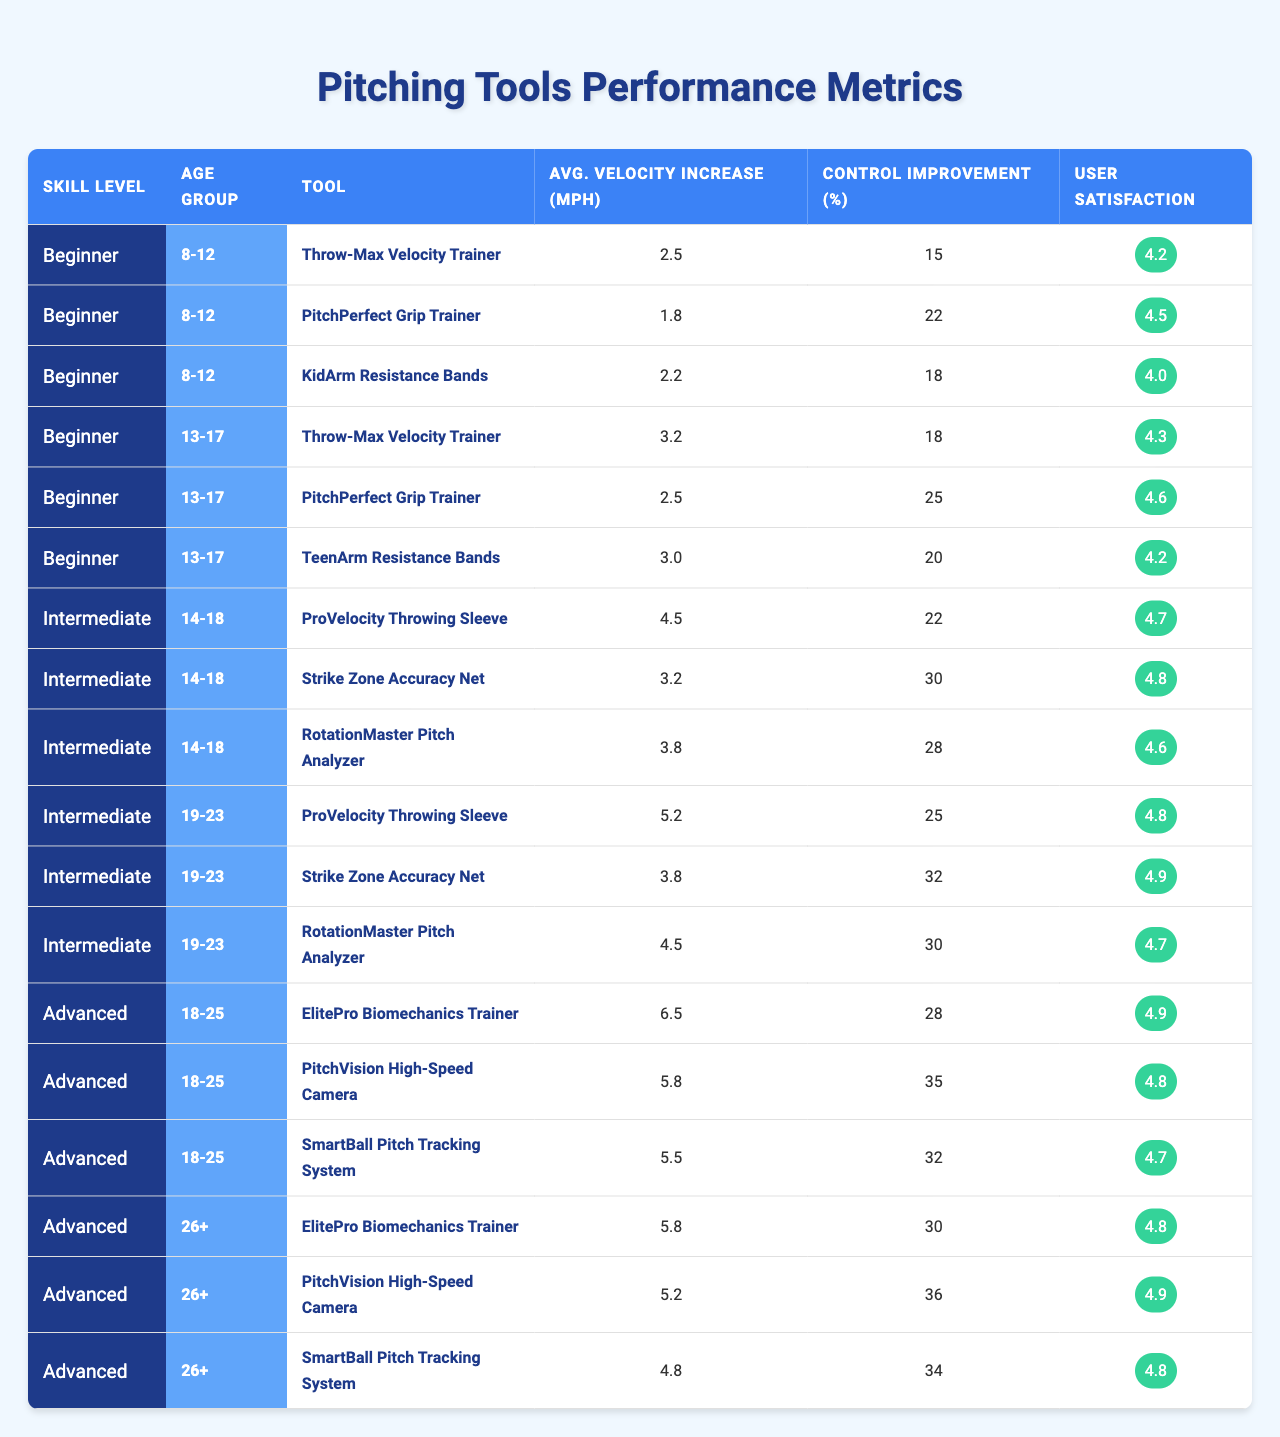What is the highest average velocity increase for tools aimed at the 8-12 age group? For the 8-12 age group, the tools are Throw-Max Velocity Trainer (2.5 mph), PitchPerfect Grip Trainer (1.8 mph), and KidArm Resistance Bands (2.2 mph). The highest average velocity increase is from the Throw-Max Velocity Trainer at 2.5 mph.
Answer: 2.5 mph Which tool has the highest user satisfaction among all age groups? Looking at all the tools across all age groups, the highest user satisfaction is 4.9, which belongs to both the Strike Zone Accuracy Net for the 19-23 age group and the PitchVision High-Speed Camera for the 18-25 age group.
Answer: 4.9 What is the control improvement percentage of the PitchPerfect Grip Trainer for the 13-17 age group? For the 13-17 age group, the PitchPerfect Grip Trainer has a control improvement percentage of 25%.
Answer: 25% Which age group shows the greatest average velocity increase for the Advanced skill level? The Advanced skill level includes the 18-25 and 26+ age groups. The 18-25 age group has an ElitePro Biomechanics Trainer at 6.5 mph, while the 26+ group has it at 5.8 mph. Thus, the greatest average velocity increase is 6.5 mph for the 18-25 age group.
Answer: 18-25 age group Does the ProVelocity Throwing Sleeve provide a higher average velocity increase for the Intermediate skill level than for the Beginner skill level? For the Intermediate skill level, the ProVelocity Throwing Sleeve has an average velocity increase of 4.5 mph (14-18 age group) and 5.2 mph (19-23 age group). For Beginners, it shows 3.2 mph for the 13-17 age group. 4.5 mph and 5.2 mph > 3.2 mph, therefore it is true that it provides a higher increase.
Answer: Yes What is the average user satisfaction for tools used in the Intermediate skill level across both age groups? The user satisfaction scores for the tools in the Intermediate skill level are: 4.7, 4.8 and 4.6 (for the 14-18 age group) and 4.8, 4.9, 4.7 (for the 19-23 age group). Summing these values gives 4.7 + 4.8 + 4.6 + 4.8 + 4.9 + 4.7 = 29.5. There are 6 tools, so the average user satisfaction is 29.5 / 6 = 4.92.
Answer: 4.92 Which tool is common across the 19-23 age group for both Intermediate and Advanced skill levels? In the 19-23 age group, the ProVelocity Throwing Sleeve is offered in the Intermediate skill level, while in the Advanced skill level, the tools are different (as they include ElitePro Biomechanics Trainer, PitchVision High-Speed Camera, and SmartBall). Thus, there is no common tool in both levels for this age group.
Answer: No common tool Which tool has the most significant control improvement percentage in the 26+ age group? For the 26+ age group, the control improvement percentages for the tools are: ElitePro Biomechanics Trainer (30%), PitchVision High-Speed Camera (36%), and SmartBall Pitch Tracking System (34%). The highest is from the PitchVision High-Speed Camera at 36%.
Answer: 36% How does the average velocity increase of the Throw-Max Velocity Trainer compare between the Beginner and Intermediate levels? The Beginner level shows an average velocity increase of 2.5 mph, while the Intermediate level (14-18 age group) has a ProVelocity Throwing Sleeve with an increase of 4.5 mph and thus higher than the Throw-Max Velocity Trainer. Therefore, the Intermediate level has a higher average increase.
Answer: Higher in Intermediate level Is there a tool that shows an average velocity increase of exactly 3 mph in the data provided? Checking the provided data, the TeenArm Resistance Bands shows an average velocity increase of 3.0 mph for the 13-17 age group.
Answer: Yes 